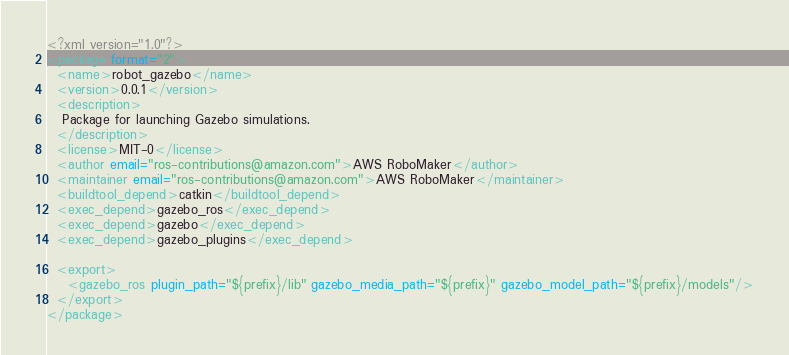<code> <loc_0><loc_0><loc_500><loc_500><_XML_><?xml version="1.0"?>
<package format="2">
  <name>robot_gazebo</name>
  <version>0.0.1</version>
  <description>
   Package for launching Gazebo simulations.
  </description>
  <license>MIT-0</license>
  <author email="ros-contributions@amazon.com">AWS RoboMaker</author>
  <maintainer email="ros-contributions@amazon.com">AWS RoboMaker</maintainer>
  <buildtool_depend>catkin</buildtool_depend>
  <exec_depend>gazebo_ros</exec_depend>
  <exec_depend>gazebo</exec_depend>
  <exec_depend>gazebo_plugins</exec_depend>

  <export>
    <gazebo_ros plugin_path="${prefix}/lib" gazebo_media_path="${prefix}" gazebo_model_path="${prefix}/models"/>
  </export>
</package>
</code> 